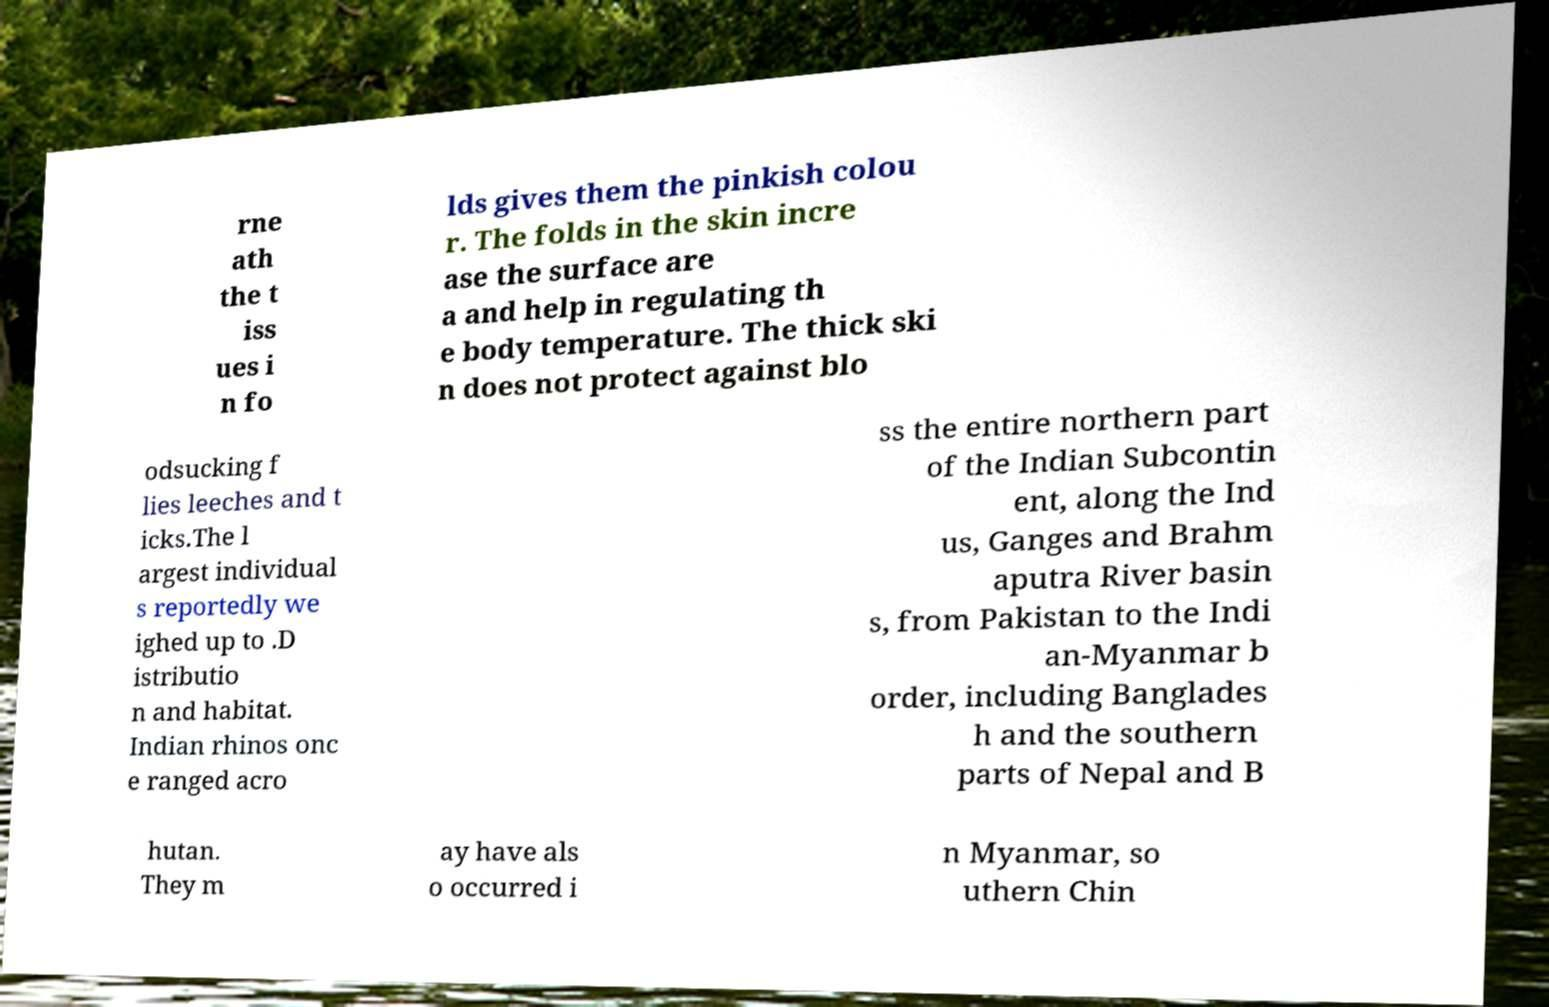I need the written content from this picture converted into text. Can you do that? rne ath the t iss ues i n fo lds gives them the pinkish colou r. The folds in the skin incre ase the surface are a and help in regulating th e body temperature. The thick ski n does not protect against blo odsucking f lies leeches and t icks.The l argest individual s reportedly we ighed up to .D istributio n and habitat. Indian rhinos onc e ranged acro ss the entire northern part of the Indian Subcontin ent, along the Ind us, Ganges and Brahm aputra River basin s, from Pakistan to the Indi an-Myanmar b order, including Banglades h and the southern parts of Nepal and B hutan. They m ay have als o occurred i n Myanmar, so uthern Chin 